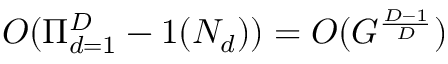<formula> <loc_0><loc_0><loc_500><loc_500>O ( \Pi _ { d = 1 } ^ { D } - 1 ( N _ { d } ) ) = O ( G ^ { \frac { D - 1 } { D } } )</formula> 